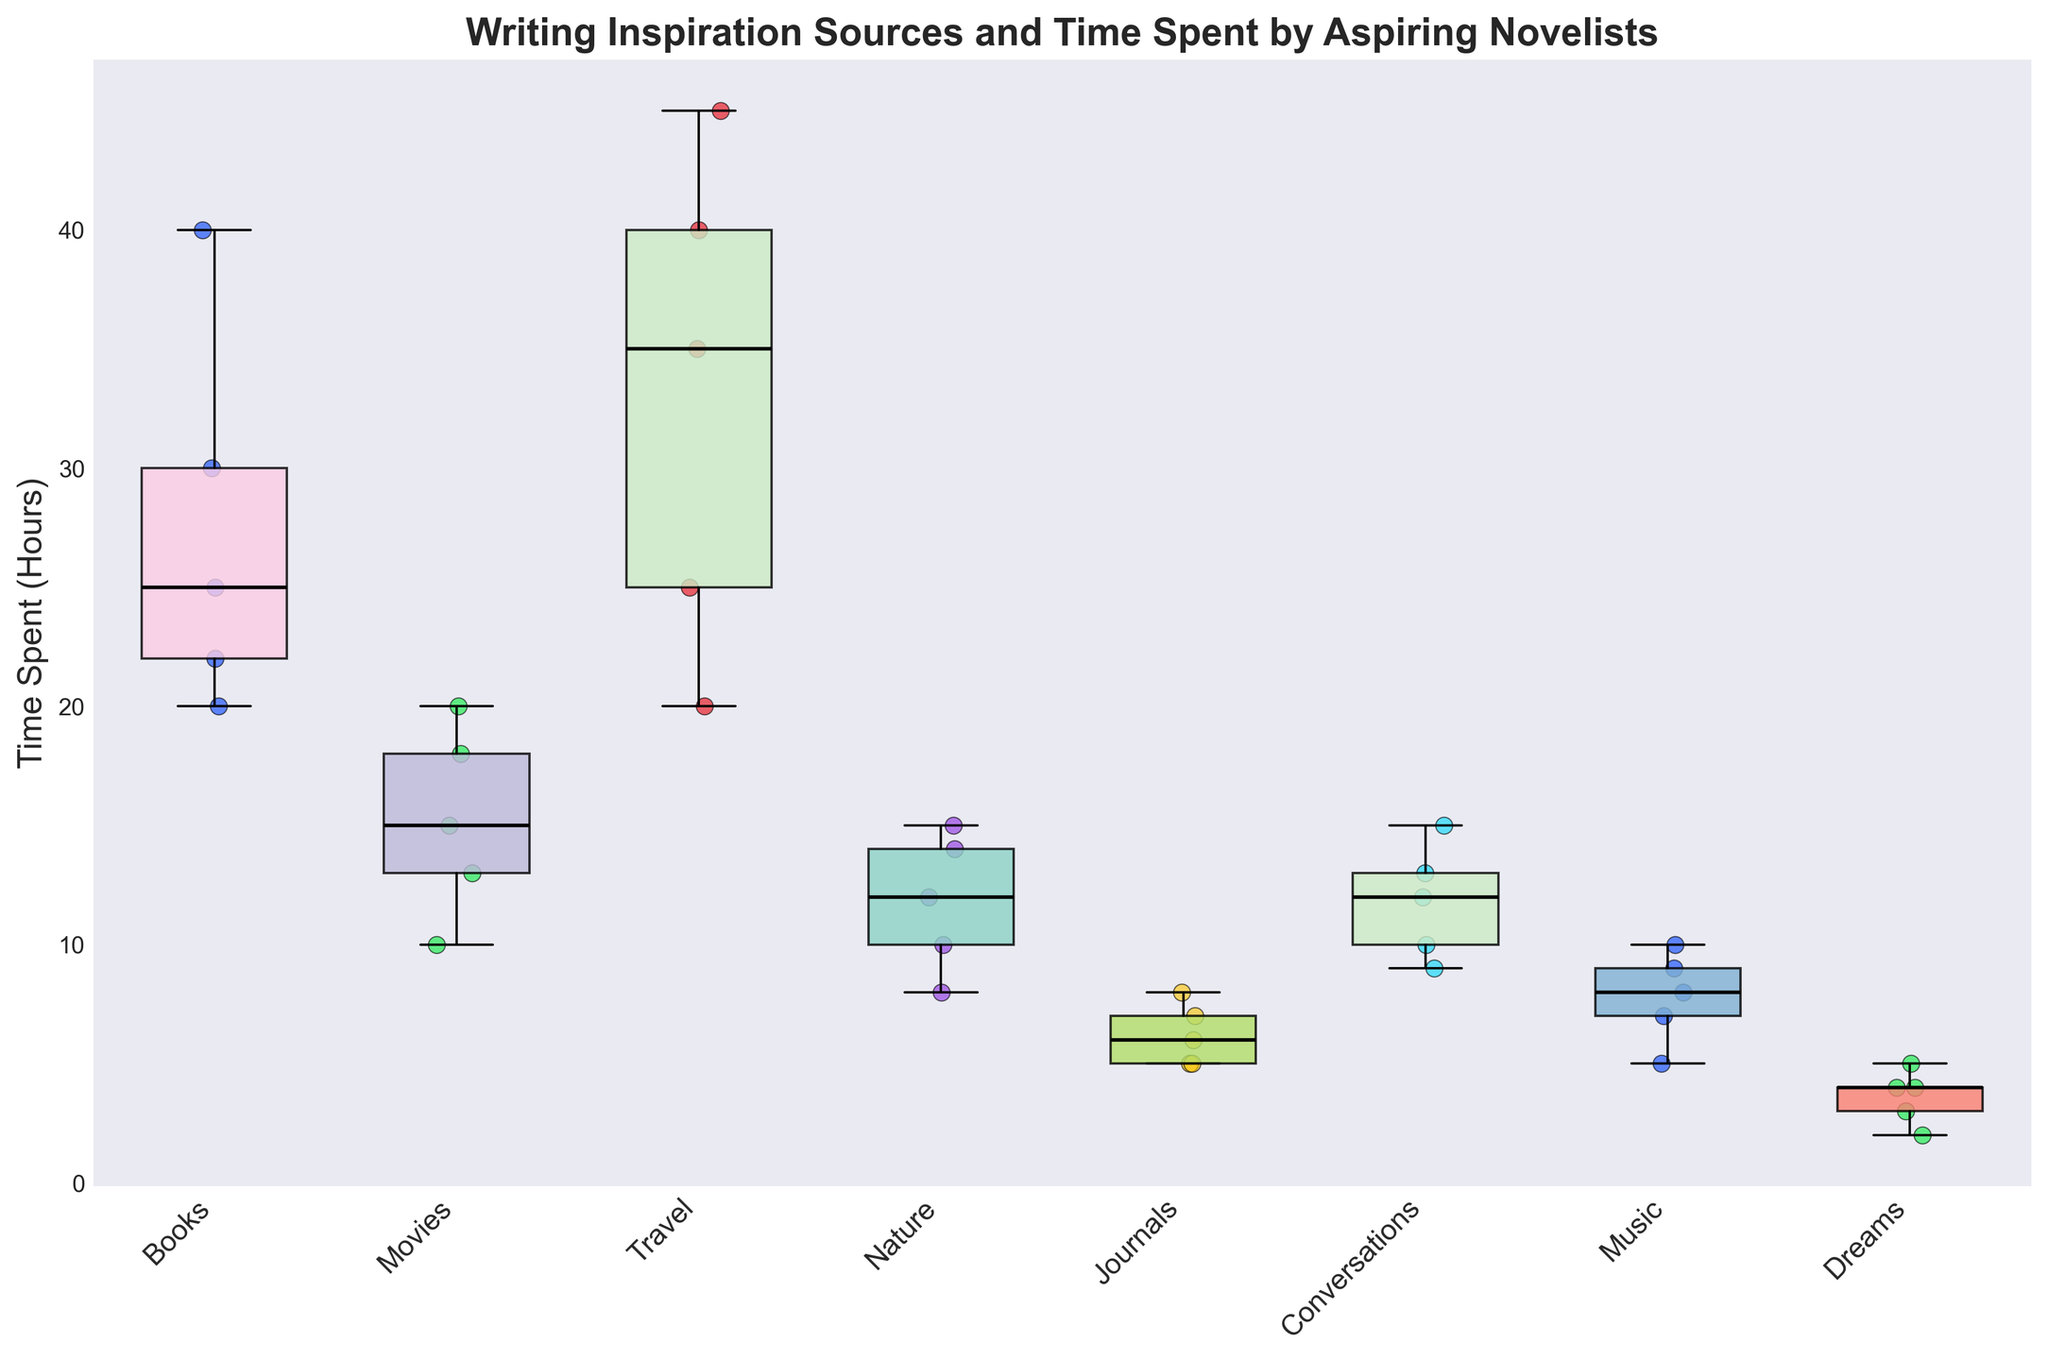What are the axis labels of the figure? The figure has two axes. The y-axis is labeled "Time Spent (Hours)" which indicates the amount of time spent in hours by aspiring novelists on their writing inspiration sources. The x-axis lists the different sources of inspiration.
Answer: "Time Spent (Hours)" and the sources of inspiration How many sources of writing inspiration are shown in the figure? By looking at the x-axis ticks or labels, we can count the number of different inspiration sources.
Answer: 7 Which source of inspiration has the highest median time spent? To determine the median, look at the middle line inside each box of the box plot. The highest middle line corresponds to "Travel".
Answer: Travel What is the approximate range of time spent on inspiration from Movies? To find the range, look at the minimum and maximum points of the whiskers of the "Movies" box. The minimum is around 10 hours and the maximum is about 20 hours.
Answer: 10 to 20 hours Which inspiration source has outliers in the data? Outliers in a box plot are typically represented by individual points outside the whiskers. In the figure, "Travel" has scatter points outside the whiskers, indicating outliers.
Answer: Travel Between Books and Music, which source shows a wider spread in the time spent? The spread can be observed by the length of the box and the whiskers. Books have a wider spread from about 20 to 40 hours compared to Music, which ranges roughly from 5 to 10 hours.
Answer: Books Which source of inspiration has the smallest interquartile range (IQR)? The interquartile range is the length of the box, indicating the middle 50% of the data. By comparing the boxes, "Journals" has the smallest IQR.
Answer: Journals What is the median time spent on inspiration from Nature? The median is the central line inside the box for "Nature". It is around 12 hours.
Answer: Approximately 12 hours How many outliers are there in the "Travel" category? Count the individual scatter points outside the whiskers of the "Travel" box. There are 2 outliers.
Answer: 2 Which source of inspiration shows the most varying time spent, and how can you tell? The source with the most variation in time spent will have the longest whiskers and the widest box. "Travel" shows the most variation as it spans from 20 to 45 hours plus outliers.
Answer: Travel 